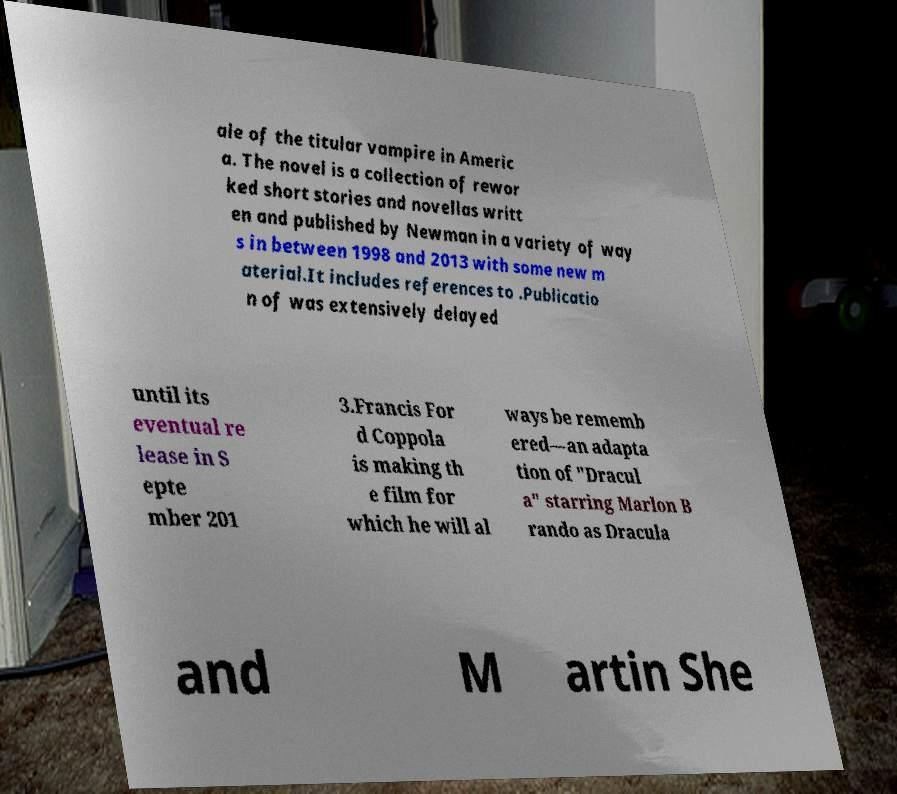Could you assist in decoding the text presented in this image and type it out clearly? ale of the titular vampire in Americ a. The novel is a collection of rewor ked short stories and novellas writt en and published by Newman in a variety of way s in between 1998 and 2013 with some new m aterial.It includes references to .Publicatio n of was extensively delayed until its eventual re lease in S epte mber 201 3.Francis For d Coppola is making th e film for which he will al ways be rememb ered—an adapta tion of "Dracul a" starring Marlon B rando as Dracula and M artin She 